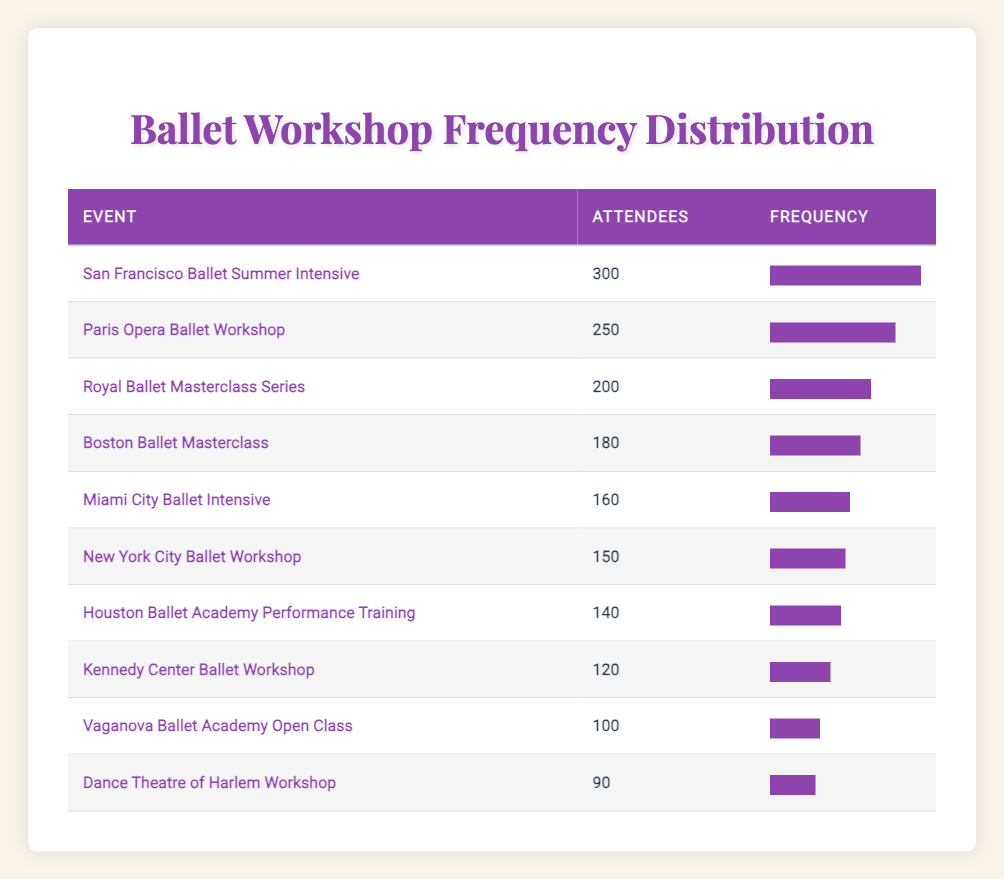What is the event with the highest number of attendees? The table lists various ballet workshops and masterclasses along with the number of attendees for each. By examining the "Attendees" column, we see that the highest number is 300, which corresponds to the "San Francisco Ballet Summer Intensive."
Answer: San Francisco Ballet Summer Intensive How many attendees did the Royal Ballet Masterclass Series have? Looking at the table, the "Royal Ballet Masterclass Series" has an entry with 200 attendees listed in the "Attendees" column.
Answer: 200 What is the total number of attendees across all events? To find the total, we need to sum the attendees of each event: 150 + 300 + 200 + 100 + 250 + 120 + 180 + 160 + 140 + 90 = 1,830. Thus, the total number of attendees is 1,830.
Answer: 1830 Is the number of attendees for the Dance Theatre of Harlem Workshop greater than the Vaganova Ballet Academy Open Class? The table shows that the "Dance Theatre of Harlem Workshop" has 90 attendees while "Vaganova Ballet Academy Open Class" has 100 attendees. Since 90 is not greater than 100, the statement is false.
Answer: No What percentage of attendees does the Paris Opera Ballet Workshop represent compared to the total number of attendees? The "Paris Opera Ballet Workshop" has 250 attendees. First, we find the total attendees as previously calculated (1,830). Then, the percentage is (250 / 1830) * 100 ≈ 13.68%. Therefore, the Paris Opera Ballet Workshop represents about 13.68% of attendees.
Answer: 13.68% Which event has the smallest number of attendees, and how many were there? By scanning the "Attendees" column, we find that the lowest number is 90, which is for the "Dance Theatre of Harlem Workshop." So, that is the event with the smallest number of attendees.
Answer: Dance Theatre of Harlem Workshop, 90 What is the difference in attendance between the Boston Ballet Masterclass and the Miami City Ballet Intensive? The "Boston Ballet Masterclass" has 180 attendees and the "Miami City Ballet Intensive" has 160 attendees. The difference is 180 - 160 = 20.
Answer: 20 How many events had more than 150 attendees? We need to count all events with attendance figures greater than 150. The events that meet this criterion are: San Francisco Ballet Summer Intensive (300), Paris Opera Ballet Workshop (250), Royal Ballet Masterclass Series (200), Boston Ballet Masterclass (180), and Miami City Ballet Intensive (160). This totals 5 events.
Answer: 5 